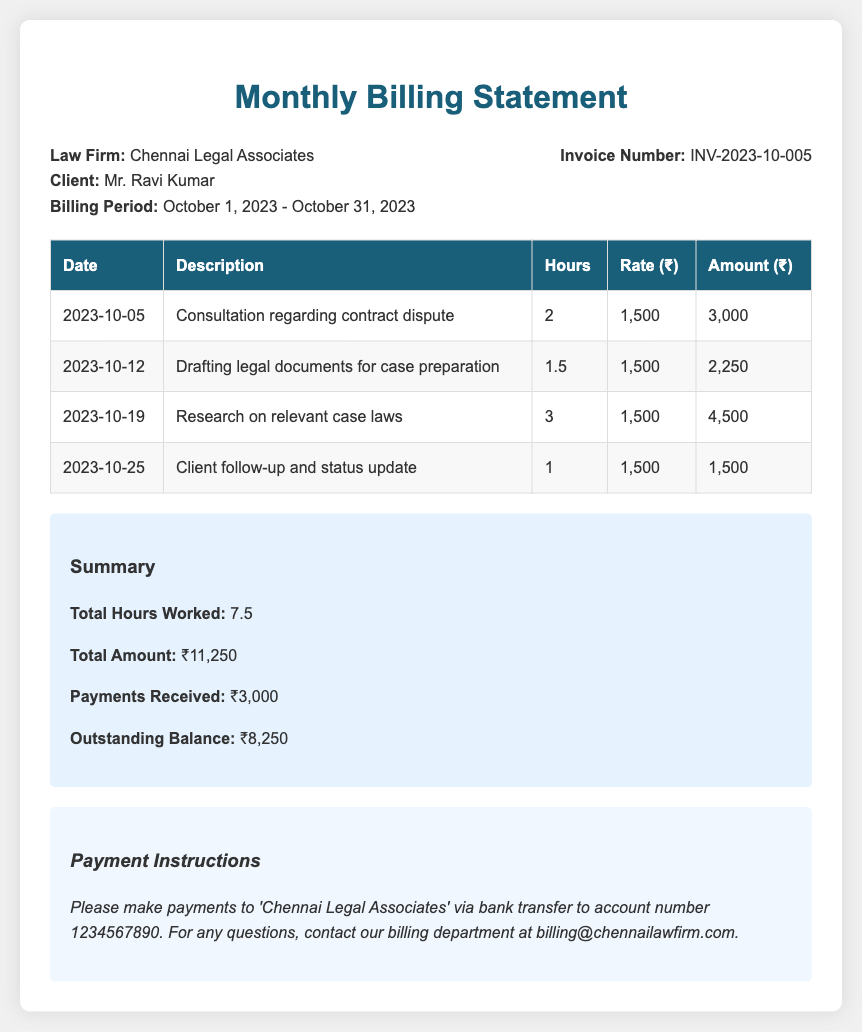What is the law firm name? The document provides the name of the law firm at the top of the billing statement.
Answer: Chennai Legal Associates Who is the client? The client name is listed in the header section of the document.
Answer: Mr. Ravi Kumar What is the billing period? The billing period is mentioned in the header section under the client information.
Answer: October 1, 2023 - October 31, 2023 What is the invoice number? The invoice number is provided in the header section of the document.
Answer: INV-2023-10-005 How many total hours were worked? The total hours worked are summarized in the summary section of the document.
Answer: 7.5 What is the total amount billed? The total amount billed is included in the summary section.
Answer: ₹11,250 What is the outstanding balance? The outstanding balance is detailed in the summary section of the document.
Answer: ₹8,250 What was the date of the client follow-up? The date of the client follow-up entry is listed in the table of hours worked.
Answer: 2023-10-25 How much was charged for the research on case laws? The amount charged for research on case laws is specified in the billing details table.
Answer: ₹4,500 